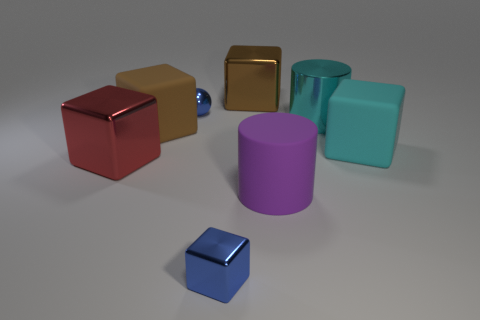Subtract 2 cubes. How many cubes are left? 3 Subtract all yellow cubes. Subtract all blue cylinders. How many cubes are left? 5 Add 1 blue rubber objects. How many objects exist? 9 Subtract all blocks. How many objects are left? 3 Subtract all big gray metal spheres. Subtract all big red metallic cubes. How many objects are left? 7 Add 3 blue shiny cubes. How many blue shiny cubes are left? 4 Add 5 blue spheres. How many blue spheres exist? 6 Subtract 0 purple spheres. How many objects are left? 8 